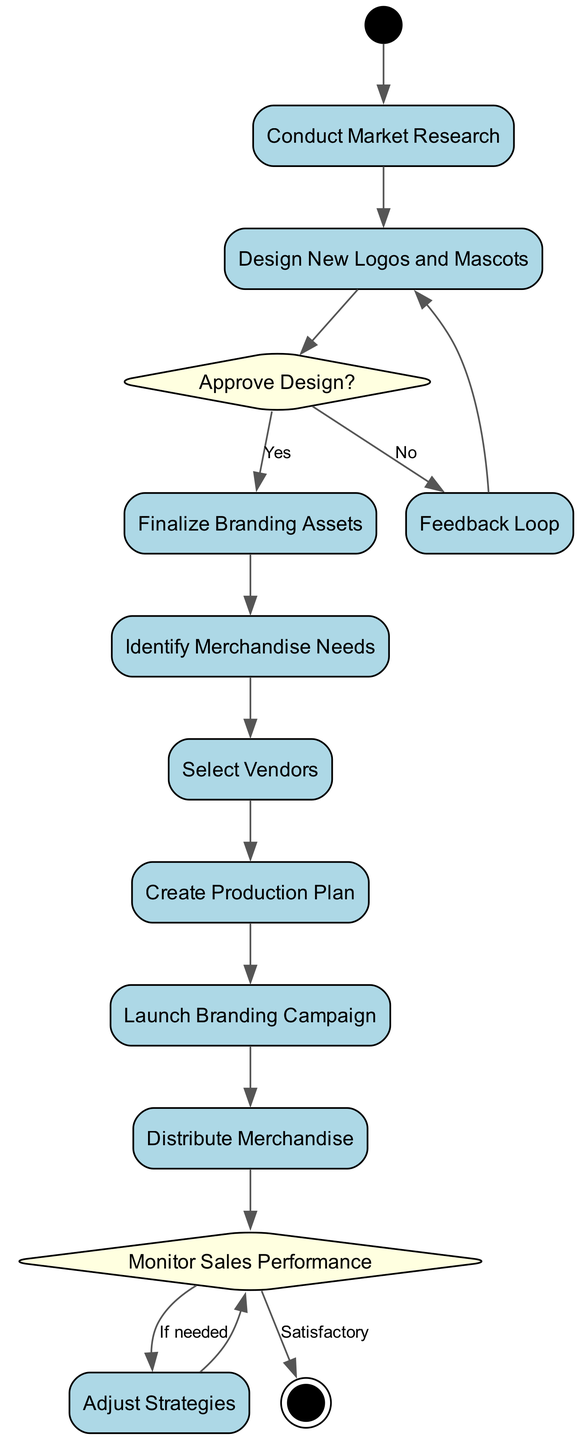What is the first activity in the diagram? The first activity node is directly connected to the Initial Node labeled 'Start'. The diagram shows that after the initial state, the flow goes to 'Conduct Market Research' as the first activity.
Answer: Conduct Market Research How many decision points are there in the diagram? The diagram features two decision points: 'Approve Design?' and 'Monitor Sales Performance'. These are represented as diamond shapes, indicating points where a yes/no decision is made.
Answer: 2 What activity follows 'Select Vendors'? After 'Select Vendors', the flow directly moves to 'Create Production Plan' as indicated by the edge connecting these two nodes in the diagram.
Answer: Create Production Plan What happens if the designs are not approved? If the designs are not approved, the flow goes to 'Feedback Loop', where feedback for revisions is provided, and then it must return to 'Design New Logos and Mascots' for re-design.
Answer: Feedback Loop What is the final outcome after 'Monitor Sales Performance'? The flow after 'Monitor Sales Performance' has two possible outcomes: if sales performance is satisfactory, it leads to 'End', otherwise it goes to 'Adjust Strategies', demonstrating a cycle for continual improvement.
Answer: End Which activity leads to the distribution of merchandise? The activity that leads to the distribution of merchandise is 'Launch Branding Campaign', as it is the step before 'Distribute Merchandise' in the flow of the diagram.
Answer: Launch Branding Campaign What will happen after 'Adjust Strategies'? After 'Adjust Strategies', the flow leads back to 'Monitor Sales Performance', indicating that this step is necessary for ongoing evaluation after adjustments are made.
Answer: Monitor Sales Performance How many activities are listed in the diagram? By counting the nodes labeled as activities, we find there are a total of seven distinct activities listed in the diagram, following the flow from start to end.
Answer: 7 